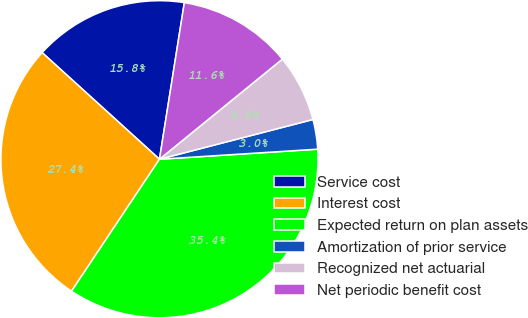<chart> <loc_0><loc_0><loc_500><loc_500><pie_chart><fcel>Service cost<fcel>Interest cost<fcel>Expected return on plan assets<fcel>Amortization of prior service<fcel>Recognized net actuarial<fcel>Net periodic benefit cost<nl><fcel>15.77%<fcel>27.38%<fcel>35.37%<fcel>3.02%<fcel>6.85%<fcel>11.61%<nl></chart> 